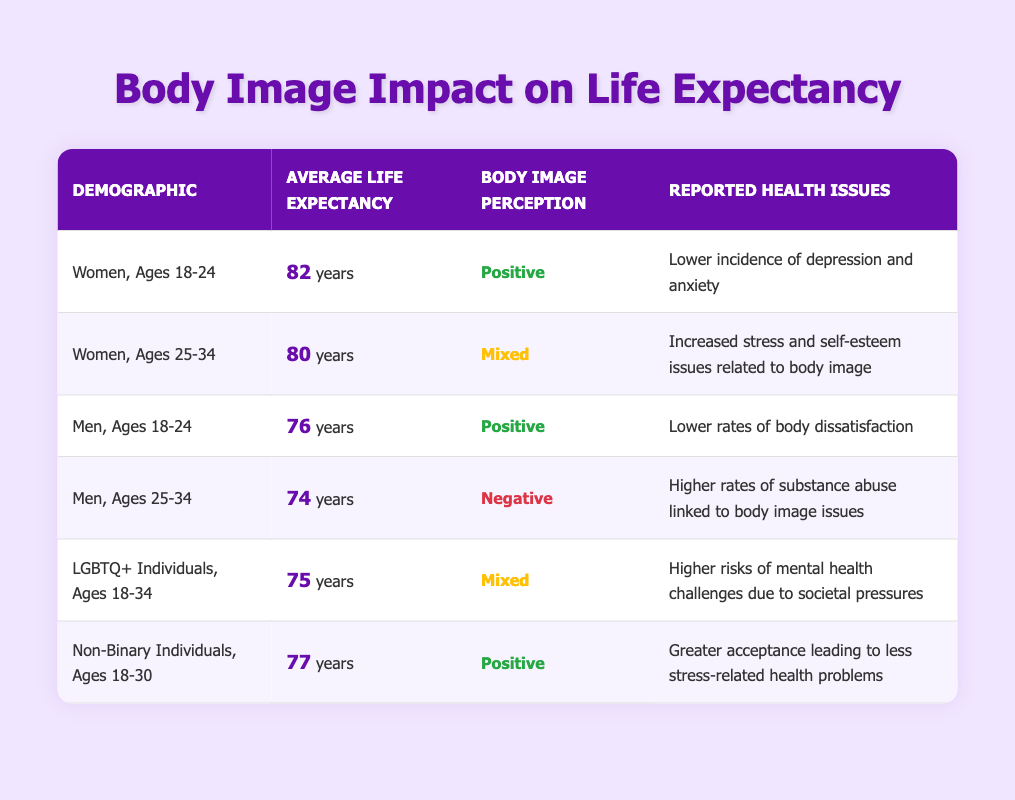What is the average life expectancy of Women, Ages 18-24? The table indicates that the average life expectancy for Women, Ages 18-24 is 82 years as stated in the corresponding row.
Answer: 82 years What body image perception is reported for Men, Ages 25-34? Looking at the row related to Men, Ages 25-34, it shows that the body image perception is classified as "Negative."
Answer: Negative What is the average life expectancy of LGBTQ+ Individuals, Ages 18-34 compared to Men, Ages 18-24? From the table, LGBTQ+ Individuals, Ages 18-34 have an average life expectancy of 75 years, while Men, Ages 18-24 have an average of 76 years. The difference is 76 - 75 = 1 year, indicating that Men, Ages 18-24 live, on average, 1 year longer.
Answer: 1 year Do Women, Ages 25-34 have a positive body image perception? The data for Women, Ages 25-34 shows a body image perception categorized as "Mixed," therefore the statement is false.
Answer: No Which demographic has the highest average life expectancy? By analyzing the table, Women, Ages 18-24 have the highest average life expectancy at 82 years. No other demographic exceeds this number.
Answer: Women, Ages 18-24 How many demographics have a positive body image perception? The table lists three demographics with a positive body image perception: Women, Ages 18-24, Men, Ages 18-24, and Non-Binary Individuals, Ages 18-30. Thus, there are three such groups.
Answer: 3 What are the reported health issues for Non-Binary Individuals, Ages 18-30? The table states that Non-Binary Individuals, Ages 18-30 report "Greater acceptance leading to less stress-related health problems," which is the information needed.
Answer: Greater acceptance leading to less stress-related health problems If we average the life expectancies of all demographics listed, what would it be? To find the average, sum the average life expectancies: 82 + 80 + 76 + 74 + 75 + 77 = 464. Then, divide by the number of demographics (6), which gives 464 / 6 = approximately 77.33.
Answer: Approximately 77.33 years How many groups have a life expectancy below 80 years? In the table, Men, Ages 25-34 (74 years), Men, Ages 18-24 (76 years), and LGBTQ+ Individuals, Ages 18-34 (75 years) all have life expectancies below 80 years. This indicates there are three such groups.
Answer: 3 